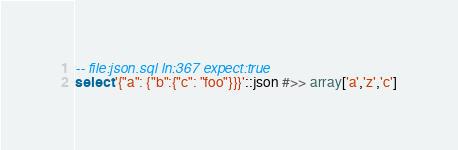<code> <loc_0><loc_0><loc_500><loc_500><_SQL_>-- file:json.sql ln:367 expect:true
select '{"a": {"b":{"c": "foo"}}}'::json #>> array['a','z','c']
</code> 